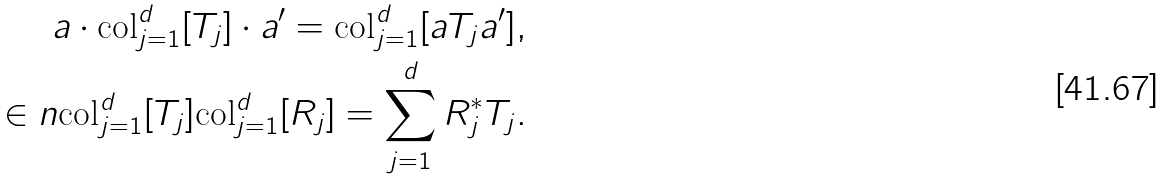<formula> <loc_0><loc_0><loc_500><loc_500>a \cdot \text {col} _ { j = 1 } ^ { d } [ T _ { j } ] \cdot a ^ { \prime } = \text {col} _ { j = 1 } ^ { d } [ a T _ { j } a ^ { \prime } ] , \\ \in n { \text {col} _ { j = 1 } ^ { d } [ T _ { j } ] } { \text {col} _ { j = 1 } ^ { d } [ R _ { j } ] } = \sum _ { j = 1 } ^ { d } R _ { j } ^ { * } T _ { j } .</formula> 